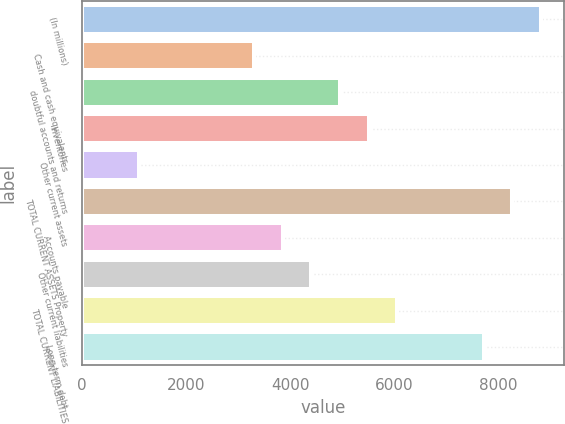Convert chart. <chart><loc_0><loc_0><loc_500><loc_500><bar_chart><fcel>(In millions)<fcel>Cash and cash equivalents<fcel>doubtful accounts and returns<fcel>Inventories<fcel>Other current assets<fcel>TOTAL CURRENT ASSETS Property<fcel>Accounts payable<fcel>Other current liabilities<fcel>TOTAL CURRENT LIABILITIES<fcel>Long-term debt<nl><fcel>8817.22<fcel>3307.52<fcel>4960.43<fcel>5511.4<fcel>1103.64<fcel>8266.25<fcel>3858.49<fcel>4409.46<fcel>6062.37<fcel>7715.28<nl></chart> 